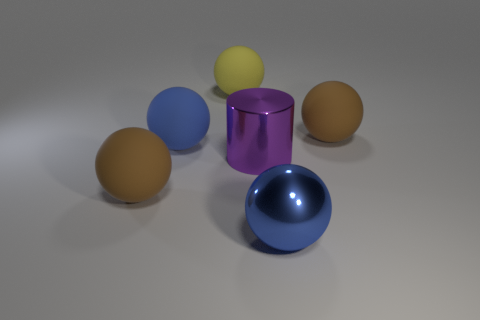Is the color of the metallic ball the same as the big metal cylinder?
Provide a short and direct response. No. What shape is the blue rubber object that is the same size as the purple thing?
Your response must be concise. Sphere. What is the size of the purple shiny cylinder?
Your answer should be compact. Large. Do the blue object on the left side of the big cylinder and the brown object that is on the left side of the big purple metallic cylinder have the same size?
Give a very brief answer. Yes. There is a shiny ball in front of the large brown object that is to the right of the yellow rubber thing; what is its color?
Provide a succinct answer. Blue. What material is the yellow ball that is the same size as the purple shiny object?
Ensure brevity in your answer.  Rubber. What number of rubber things are either big brown spheres or yellow things?
Your response must be concise. 3. What is the color of the ball that is in front of the large metal cylinder and to the right of the big yellow rubber thing?
Provide a succinct answer. Blue. How many cylinders are right of the purple object?
Offer a very short reply. 0. What material is the large yellow object?
Give a very brief answer. Rubber. 